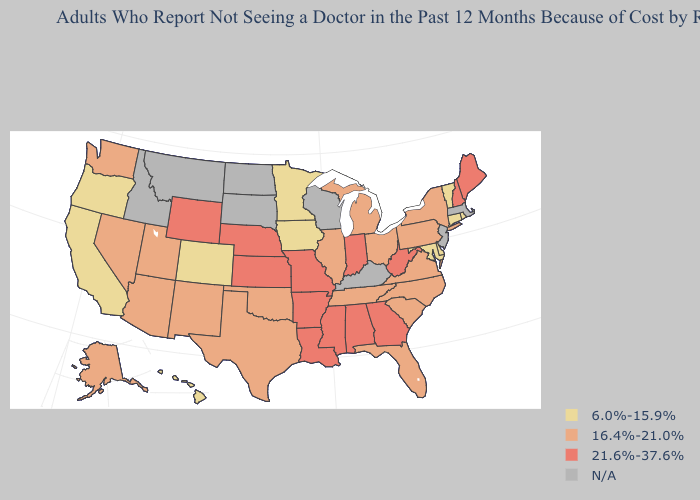Which states hav the highest value in the MidWest?
Short answer required. Indiana, Kansas, Missouri, Nebraska. Does Maine have the highest value in the USA?
Concise answer only. Yes. What is the value of Massachusetts?
Concise answer only. N/A. What is the value of California?
Give a very brief answer. 6.0%-15.9%. Which states have the lowest value in the USA?
Keep it brief. California, Colorado, Connecticut, Delaware, Hawaii, Iowa, Maryland, Minnesota, Oregon, Rhode Island, Vermont. What is the value of Minnesota?
Answer briefly. 6.0%-15.9%. Which states have the lowest value in the USA?
Answer briefly. California, Colorado, Connecticut, Delaware, Hawaii, Iowa, Maryland, Minnesota, Oregon, Rhode Island, Vermont. Does Maryland have the lowest value in the South?
Quick response, please. Yes. Name the states that have a value in the range 21.6%-37.6%?
Quick response, please. Alabama, Arkansas, Georgia, Indiana, Kansas, Louisiana, Maine, Mississippi, Missouri, Nebraska, New Hampshire, West Virginia, Wyoming. Name the states that have a value in the range N/A?
Give a very brief answer. Idaho, Kentucky, Massachusetts, Montana, New Jersey, North Dakota, South Dakota, Wisconsin. How many symbols are there in the legend?
Write a very short answer. 4. What is the value of Montana?
Quick response, please. N/A. What is the value of New Mexico?
Short answer required. 16.4%-21.0%. Does the first symbol in the legend represent the smallest category?
Quick response, please. Yes. What is the lowest value in the MidWest?
Write a very short answer. 6.0%-15.9%. 